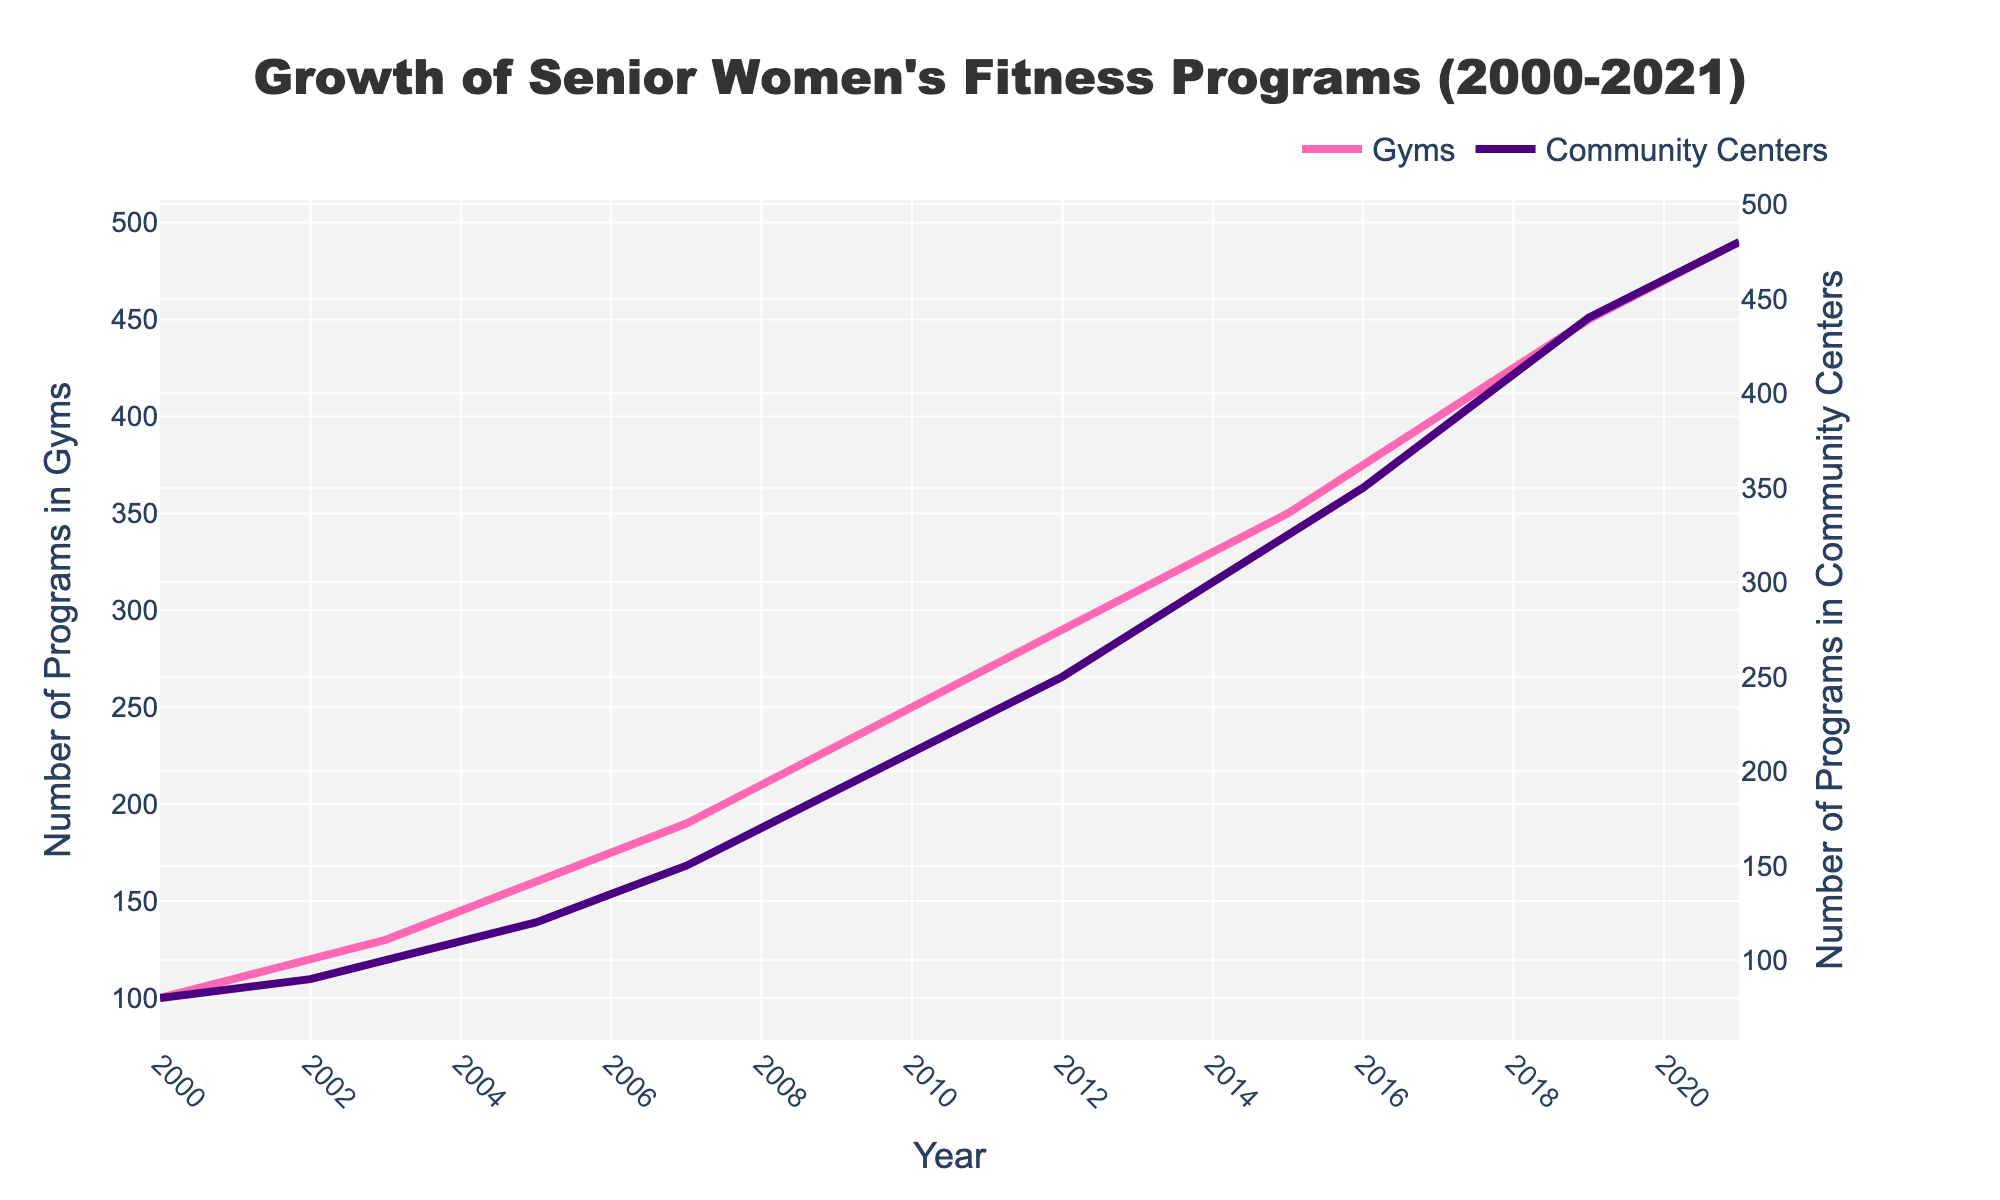What is the title of the figure? The title of the figure is displayed prominently at the top and summarizes the overall content. It is important for understanding what the plot represents.
Answer: Growth of Senior Women's Fitness Programs (2000-2021) How many fitness programs were there in gyms in the year 2000? The number of programs in gyms for a specific year can be found by locating the corresponding point on the plot.
Answer: 100 What was the difference in the number of programs in gyms and community centers in 2021? To find the difference, locate the values for both gyms and community centers for the year 2021 and subtract one from the other.
Answer: 10 Between which years did the number of fitness programs in community centers first exceed 200? To determine this, look at the trendline for community centers and note the year it surpasses 200 for the first time.
Answer: 2010 Which year saw the highest growth rate in fitness programs in gyms? Identify the year with the largest increase by comparing year-over-year increments on the plot.
Answer: Multiple steps: Calculate the year-over-year changes for gyms (e.g., 110-100 for 2001) and identify the year with the largest change By how many programs did the number of community center programs increase from 2000 to 2015? To find this, identify the number of programs at both starting and ending years and subtract the initial value from the final value.
Answer: 245 Did the number of fitness programs in gyms ever decrease over the years? Observe the trendline for gyms. If there are any downward slopes, then there was a decrease; otherwise, it consistently increased.
Answer: No What is the gap between the number of gym and community center programs in the year 2019? Locate the values for both gyms and community centers for 2019 and calculate their difference.
Answer: 10 In what year did the number of fitness programs in gyms reach 300? Find the year where the value on the gym's plot first intersects with the value 300.
Answer: 2013 Did the programs in community centers grow at a faster rate than those in gyms from 2000 to 2021? Compare the overall trends and slopes of the plots for both gyms and community centers over the given years.
Answer: No 